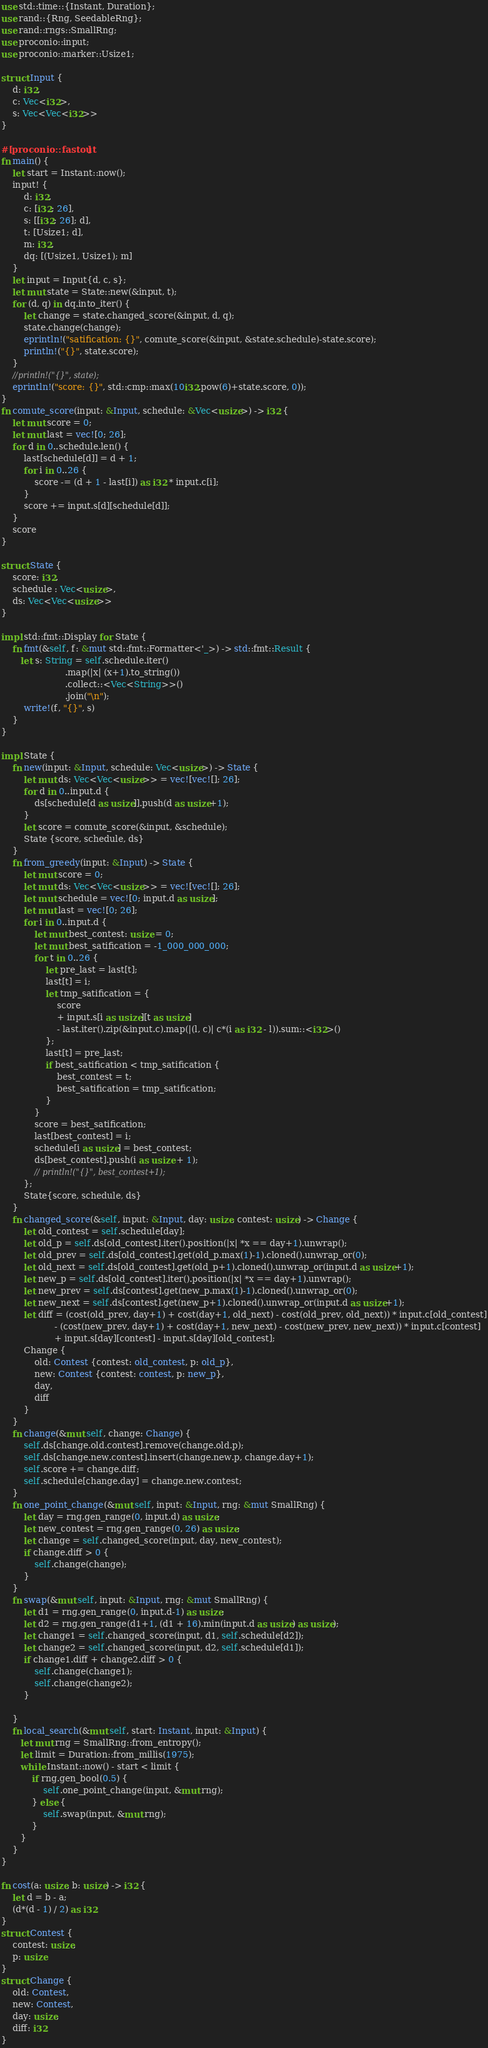<code> <loc_0><loc_0><loc_500><loc_500><_Rust_>use std::time::{Instant, Duration};
use rand::{Rng, SeedableRng};
use rand::rngs::SmallRng;
use proconio::input;
use proconio::marker::Usize1;

struct Input {
    d: i32,
    c: Vec<i32>,
    s: Vec<Vec<i32>>
}

#[proconio::fastout]
fn main() {
    let start = Instant::now();
    input! {
        d: i32,
        c: [i32; 26],
        s: [[i32; 26]; d],
        t: [Usize1; d],
        m: i32,
        dq: [(Usize1, Usize1); m]
    }
    let input = Input{d, c, s};
    let mut state = State::new(&input, t);
    for (d, q) in dq.into_iter() {
        let change = state.changed_score(&input, d, q);
        state.change(change);
        eprintln!("satification: {}", comute_score(&input, &state.schedule)-state.score);
        println!("{}", state.score);
    }
    //println!("{}", state);
    eprintln!("score: {}", std::cmp::max(10i32.pow(6)+state.score, 0));
}
fn comute_score(input: &Input, schedule: &Vec<usize>) -> i32 {
    let mut score = 0;
    let mut last = vec![0; 26];
    for d in 0..schedule.len() {
        last[schedule[d]] = d + 1;
        for i in 0..26 {
            score -= (d + 1 - last[i]) as i32 * input.c[i];
        }
        score += input.s[d][schedule[d]];
    }
    score
}

struct State {
    score: i32,
    schedule : Vec<usize>,
    ds: Vec<Vec<usize>>
}

impl std::fmt::Display for State {
    fn fmt(&self, f: &mut std::fmt::Formatter<'_>) -> std::fmt::Result {
       let s: String = self.schedule.iter()
                       .map(|x| (x+1).to_string())
                       .collect::<Vec<String>>()
                       .join("\n");
        write!(f, "{}", s)
    }
}

impl State {
    fn new(input: &Input, schedule: Vec<usize>) -> State {
        let mut ds: Vec<Vec<usize>> = vec![vec![]; 26];
        for d in 0..input.d {
            ds[schedule[d as usize]].push(d as usize+1);
        }
        let score = comute_score(&input, &schedule);
        State {score, schedule, ds}
    }
    fn from_greedy(input: &Input) -> State {
        let mut score = 0;
        let mut ds: Vec<Vec<usize>> = vec![vec![]; 26];
        let mut schedule = vec![0; input.d as usize];
        let mut last = vec![0; 26];
        for i in 0..input.d {
            let mut best_contest: usize = 0;
            let mut best_satification = -1_000_000_000;
            for t in 0..26 {
                let pre_last = last[t];
                last[t] = i;
                let tmp_satification = {
                    score
                    + input.s[i as usize][t as usize]
                    - last.iter().zip(&input.c).map(|(l, c)| c*(i as i32 - l)).sum::<i32>()
                };
                last[t] = pre_last;
                if best_satification < tmp_satification {
                    best_contest = t;
                    best_satification = tmp_satification;
                }
            }
            score = best_satification;
            last[best_contest] = i;
            schedule[i as usize] = best_contest;
            ds[best_contest].push(i as usize + 1);
            // println!("{}", best_contest+1);
        };
        State{score, schedule, ds}
    }
    fn changed_score(&self, input: &Input, day: usize, contest: usize) -> Change {
        let old_contest = self.schedule[day];
        let old_p = self.ds[old_contest].iter().position(|x| *x == day+1).unwrap();
        let old_prev = self.ds[old_contest].get(old_p.max(1)-1).cloned().unwrap_or(0);
        let old_next = self.ds[old_contest].get(old_p+1).cloned().unwrap_or(input.d as usize+1);
        let new_p = self.ds[old_contest].iter().position(|x| *x == day+1).unwrap();
        let new_prev = self.ds[contest].get(new_p.max(1)-1).cloned().unwrap_or(0);
        let new_next = self.ds[contest].get(new_p+1).cloned().unwrap_or(input.d as usize+1);
        let diff = (cost(old_prev, day+1) + cost(day+1, old_next) - cost(old_prev, old_next)) * input.c[old_contest]
                   - (cost(new_prev, day+1) + cost(day+1, new_next) - cost(new_prev, new_next)) * input.c[contest]
                   + input.s[day][contest] - input.s[day][old_contest];
        Change {
            old: Contest {contest: old_contest, p: old_p},
            new: Contest {contest: contest, p: new_p},
            day,
            diff
        }
    }
    fn change(&mut self, change: Change) {
        self.ds[change.old.contest].remove(change.old.p);
        self.ds[change.new.contest].insert(change.new.p, change.day+1);
        self.score += change.diff;
        self.schedule[change.day] = change.new.contest;
    }
    fn one_point_change(&mut self, input: &Input, rng: &mut SmallRng) {
        let day = rng.gen_range(0, input.d) as usize;
        let new_contest = rng.gen_range(0, 26) as usize;
        let change = self.changed_score(input, day, new_contest);
        if change.diff > 0 {
            self.change(change);
        }
    }
    fn swap(&mut self, input: &Input, rng: &mut SmallRng) {
        let d1 = rng.gen_range(0, input.d-1) as usize;
        let d2 = rng.gen_range(d1+1, (d1 + 16).min(input.d as usize) as usize);
        let change1 = self.changed_score(input, d1, self.schedule[d2]);
        let change2 = self.changed_score(input, d2, self.schedule[d1]);
        if change1.diff + change2.diff > 0 {
            self.change(change1);
            self.change(change2);
        }

    }
    fn local_search(&mut self, start: Instant, input: &Input) {
       let mut rng = SmallRng::from_entropy();
       let limit = Duration::from_millis(1975);
       while Instant::now() - start < limit {
           if rng.gen_bool(0.5) {
               self.one_point_change(input, &mut rng);
           } else {
               self.swap(input, &mut rng);
           }
       } 
    }
}

fn cost(a: usize, b: usize) -> i32 {
    let d = b - a;
    (d*(d - 1) / 2) as i32
}
struct Contest {
    contest: usize,
    p: usize
}
struct Change {
    old: Contest,
    new: Contest,
    day: usize,
    diff: i32
}</code> 